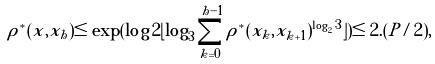<formula> <loc_0><loc_0><loc_500><loc_500>\rho ^ { * } ( x , x _ { h } ) \leq \exp ( \log 2 \lfloor \log _ { 3 } \sum _ { k = 0 } ^ { h - 1 } { \rho ^ { * } ( x _ { k } , x _ { k + 1 } ) ^ { \log _ { 2 } 3 } } \rfloor ) \leq 2 . ( P / 2 ) ,</formula> 